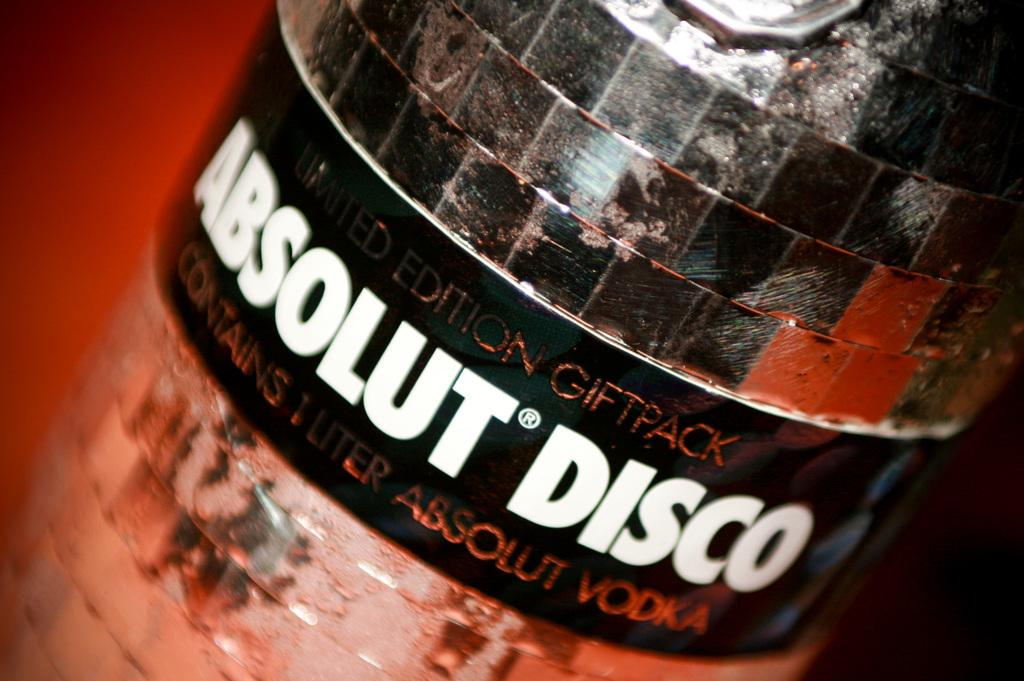<image>
Share a concise interpretation of the image provided. a bottle of absolut disco vodka in the special edition giftpack 